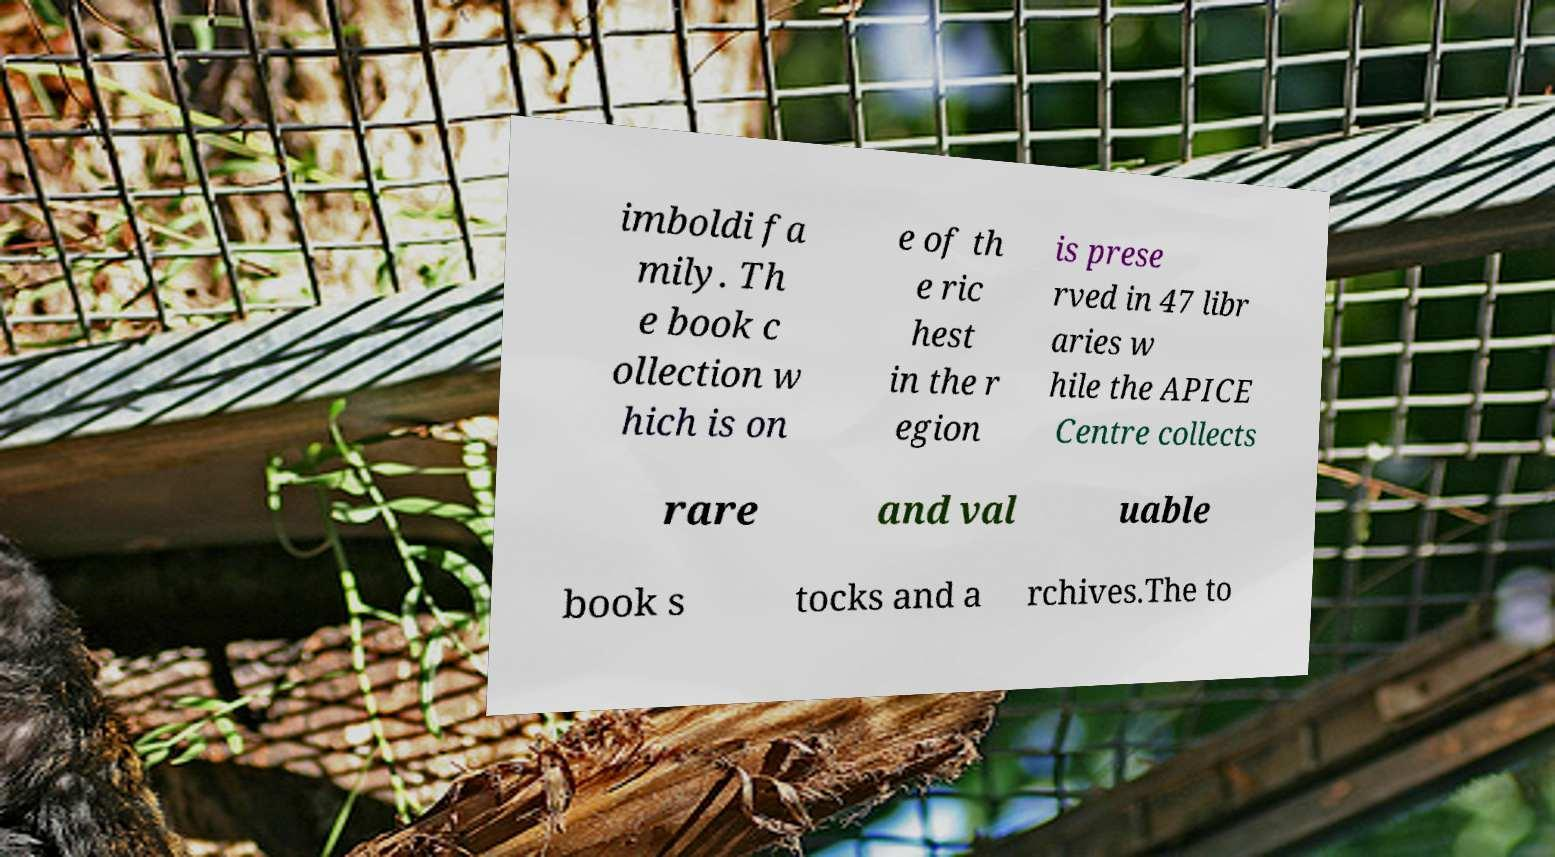Could you extract and type out the text from this image? imboldi fa mily. Th e book c ollection w hich is on e of th e ric hest in the r egion is prese rved in 47 libr aries w hile the APICE Centre collects rare and val uable book s tocks and a rchives.The to 